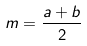<formula> <loc_0><loc_0><loc_500><loc_500>m = \frac { a + b } { 2 }</formula> 